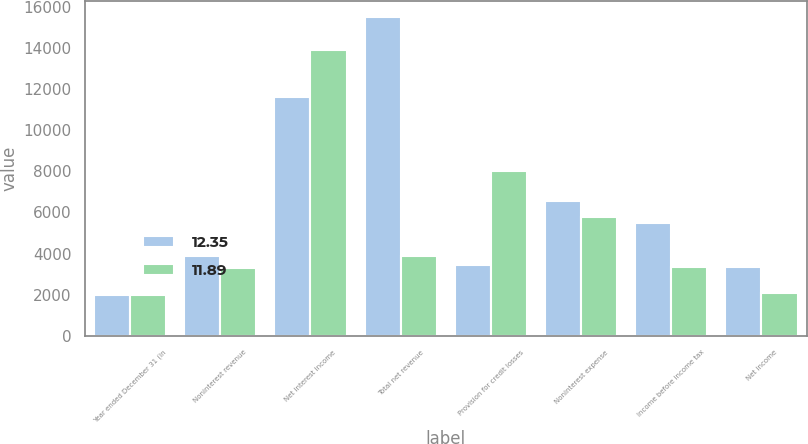Convert chart. <chart><loc_0><loc_0><loc_500><loc_500><stacked_bar_chart><ecel><fcel>Year ended December 31 (in<fcel>Noninterest revenue<fcel>Net interest income<fcel>Total net revenue<fcel>Provision for credit losses<fcel>Noninterest expense<fcel>Income before income tax<fcel>Net income<nl><fcel>12.35<fcel>2012<fcel>3887<fcel>11611<fcel>15498<fcel>3444<fcel>6566<fcel>5488<fcel>3344<nl><fcel>11.89<fcel>2010<fcel>3277<fcel>13886<fcel>3887<fcel>8037<fcel>5797<fcel>3329<fcel>2074<nl></chart> 